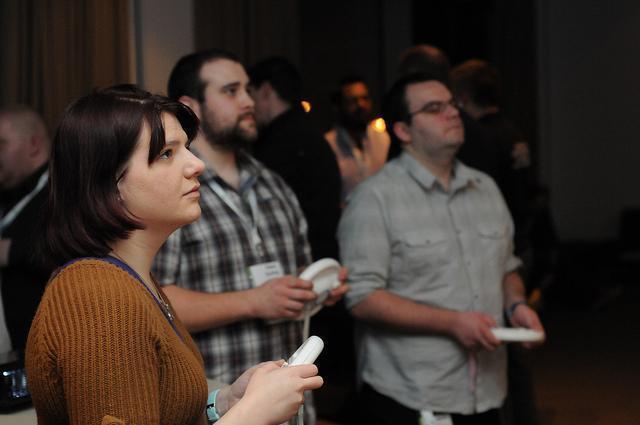What part of a car is symbolized in the objects they are holding?
Select the accurate answer and provide explanation: 'Answer: answer
Rationale: rationale.'
Options: Seatbelt, radio, steering wheel, headlights. Answer: steering wheel.
Rationale: They are holding a circular controller that resembles the part of a car that drivers use to control the direction the car travels. 